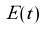Convert formula to latex. <formula><loc_0><loc_0><loc_500><loc_500>\tilde { E } ( t )</formula> 